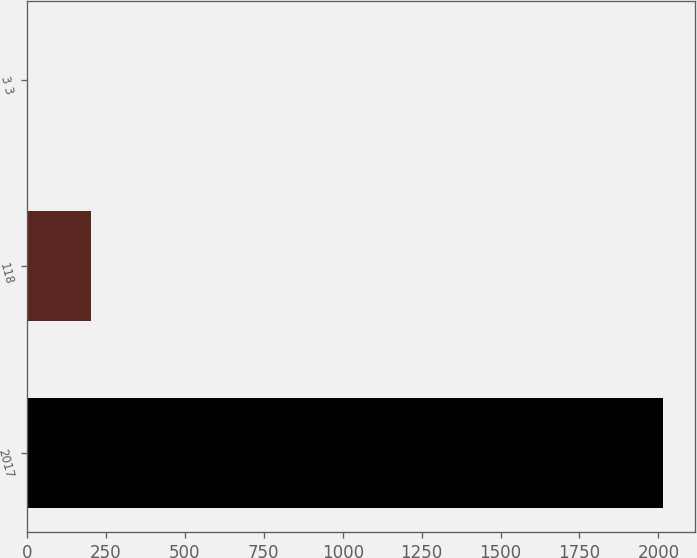<chart> <loc_0><loc_0><loc_500><loc_500><bar_chart><fcel>2017<fcel>118<fcel>3 3<nl><fcel>2016<fcel>203.4<fcel>2<nl></chart> 